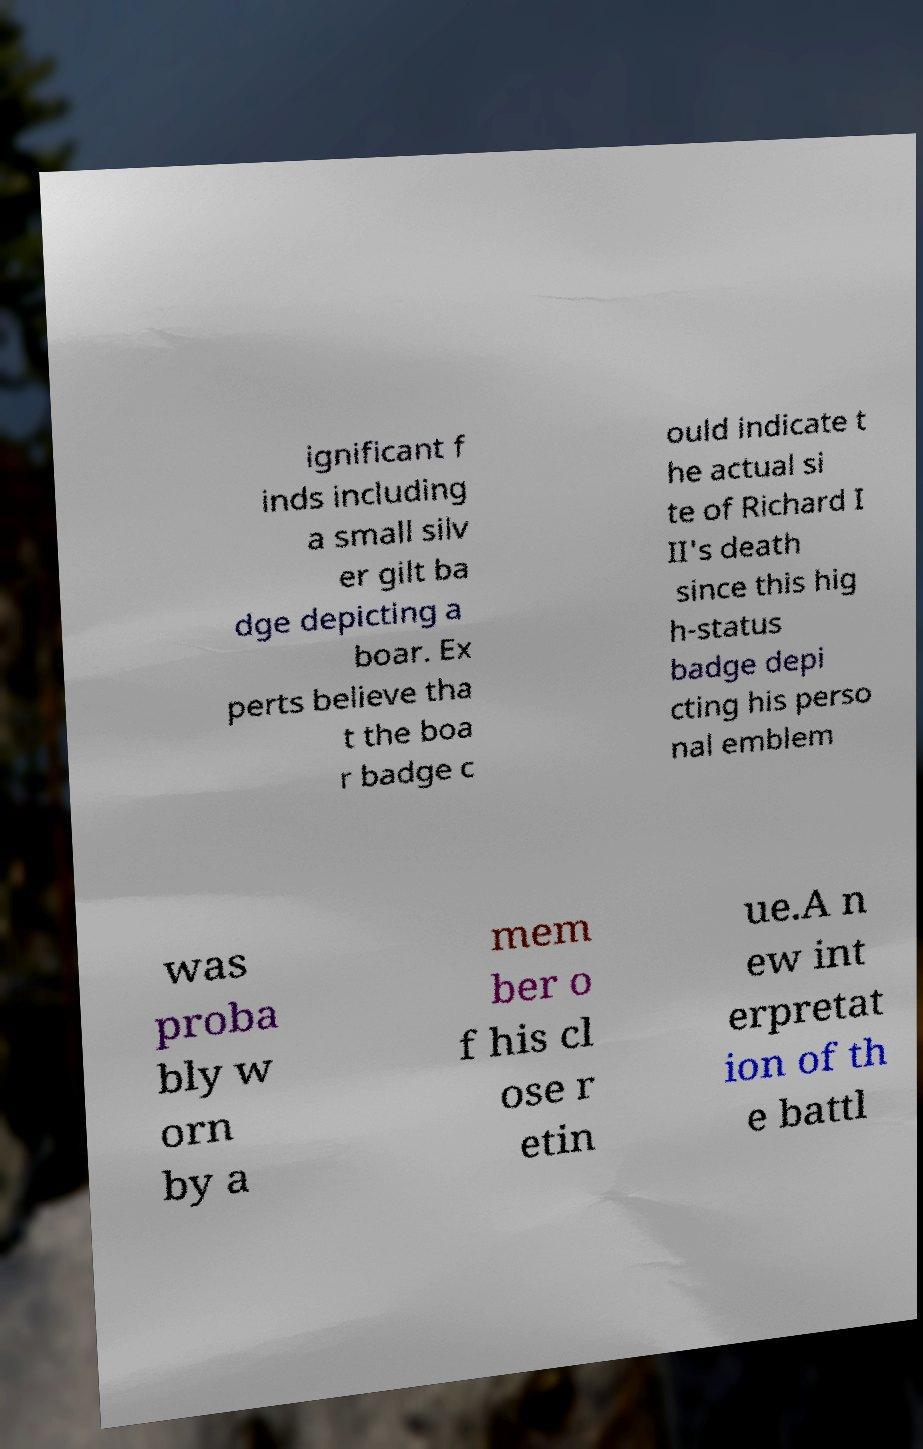Could you assist in decoding the text presented in this image and type it out clearly? ignificant f inds including a small silv er gilt ba dge depicting a boar. Ex perts believe tha t the boa r badge c ould indicate t he actual si te of Richard I II's death since this hig h-status badge depi cting his perso nal emblem was proba bly w orn by a mem ber o f his cl ose r etin ue.A n ew int erpretat ion of th e battl 